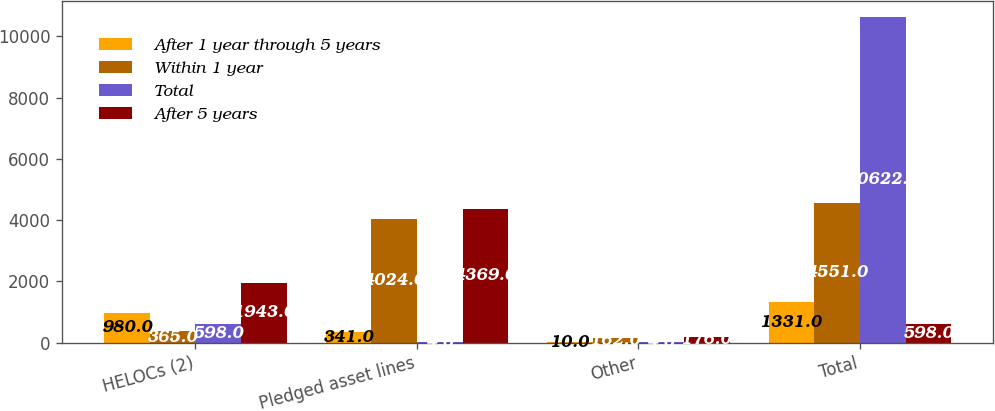Convert chart to OTSL. <chart><loc_0><loc_0><loc_500><loc_500><stacked_bar_chart><ecel><fcel>HELOCs (2)<fcel>Pledged asset lines<fcel>Other<fcel>Total<nl><fcel>After 1 year through 5 years<fcel>980<fcel>341<fcel>10<fcel>1331<nl><fcel>Within 1 year<fcel>365<fcel>4024<fcel>162<fcel>4551<nl><fcel>Total<fcel>598<fcel>4<fcel>4<fcel>10622<nl><fcel>After 5 years<fcel>1943<fcel>4369<fcel>176<fcel>598<nl></chart> 